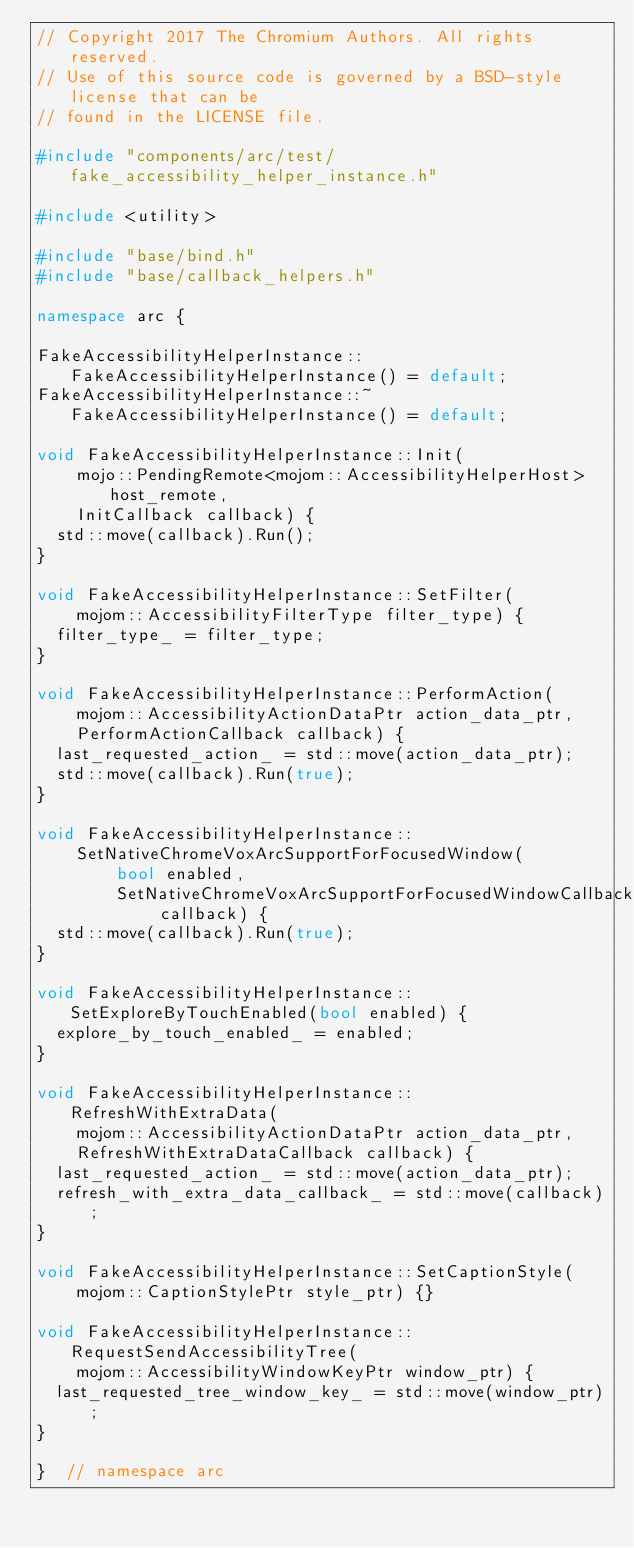<code> <loc_0><loc_0><loc_500><loc_500><_C++_>// Copyright 2017 The Chromium Authors. All rights reserved.
// Use of this source code is governed by a BSD-style license that can be
// found in the LICENSE file.

#include "components/arc/test/fake_accessibility_helper_instance.h"

#include <utility>

#include "base/bind.h"
#include "base/callback_helpers.h"

namespace arc {

FakeAccessibilityHelperInstance::FakeAccessibilityHelperInstance() = default;
FakeAccessibilityHelperInstance::~FakeAccessibilityHelperInstance() = default;

void FakeAccessibilityHelperInstance::Init(
    mojo::PendingRemote<mojom::AccessibilityHelperHost> host_remote,
    InitCallback callback) {
  std::move(callback).Run();
}

void FakeAccessibilityHelperInstance::SetFilter(
    mojom::AccessibilityFilterType filter_type) {
  filter_type_ = filter_type;
}

void FakeAccessibilityHelperInstance::PerformAction(
    mojom::AccessibilityActionDataPtr action_data_ptr,
    PerformActionCallback callback) {
  last_requested_action_ = std::move(action_data_ptr);
  std::move(callback).Run(true);
}

void FakeAccessibilityHelperInstance::
    SetNativeChromeVoxArcSupportForFocusedWindow(
        bool enabled,
        SetNativeChromeVoxArcSupportForFocusedWindowCallback callback) {
  std::move(callback).Run(true);
}

void FakeAccessibilityHelperInstance::SetExploreByTouchEnabled(bool enabled) {
  explore_by_touch_enabled_ = enabled;
}

void FakeAccessibilityHelperInstance::RefreshWithExtraData(
    mojom::AccessibilityActionDataPtr action_data_ptr,
    RefreshWithExtraDataCallback callback) {
  last_requested_action_ = std::move(action_data_ptr);
  refresh_with_extra_data_callback_ = std::move(callback);
}

void FakeAccessibilityHelperInstance::SetCaptionStyle(
    mojom::CaptionStylePtr style_ptr) {}

void FakeAccessibilityHelperInstance::RequestSendAccessibilityTree(
    mojom::AccessibilityWindowKeyPtr window_ptr) {
  last_requested_tree_window_key_ = std::move(window_ptr);
}

}  // namespace arc
</code> 